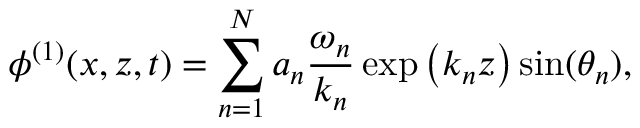Convert formula to latex. <formula><loc_0><loc_0><loc_500><loc_500>\phi ^ { ( 1 ) } ( x , z , t ) = \sum _ { n = 1 } ^ { N } a _ { n } \frac { \omega _ { n } } { k _ { n } } \exp \left ( k _ { n } z \right ) \sin ( \theta _ { n } ) ,</formula> 